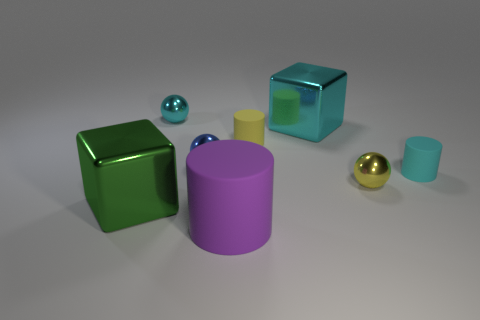What shape is the large object that is in front of the tiny cyan matte object and on the right side of the green metallic thing?
Keep it short and to the point. Cylinder. Are there any other things that have the same material as the cyan cylinder?
Ensure brevity in your answer.  Yes. Are there fewer yellow metallic spheres that are to the left of the small blue metal ball than large cylinders?
Make the answer very short. Yes. What size is the cyan matte thing that is the same shape as the tiny yellow rubber object?
Give a very brief answer. Small. How many small blue spheres are the same material as the small cyan sphere?
Provide a succinct answer. 1. Is the material of the big block behind the big green object the same as the big purple object?
Your response must be concise. No. Is the number of small cyan metallic things to the right of the blue metal sphere the same as the number of cyan matte objects?
Provide a succinct answer. No. What size is the purple object?
Give a very brief answer. Large. Is the yellow metallic sphere the same size as the cyan rubber object?
Provide a succinct answer. Yes. How big is the metal block that is in front of the big metal block behind the yellow matte object?
Ensure brevity in your answer.  Large. 